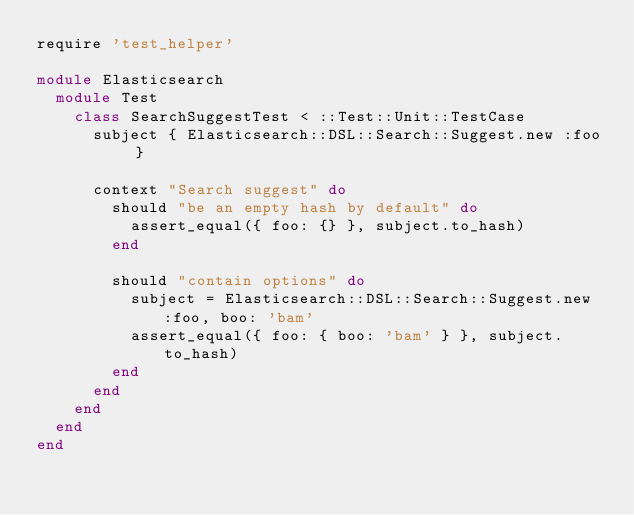<code> <loc_0><loc_0><loc_500><loc_500><_Ruby_>require 'test_helper'

module Elasticsearch
  module Test
    class SearchSuggestTest < ::Test::Unit::TestCase
      subject { Elasticsearch::DSL::Search::Suggest.new :foo }

      context "Search suggest" do
        should "be an empty hash by default" do
          assert_equal({ foo: {} }, subject.to_hash)
        end

        should "contain options" do
          subject = Elasticsearch::DSL::Search::Suggest.new :foo, boo: 'bam'
          assert_equal({ foo: { boo: 'bam' } }, subject.to_hash)
        end
      end
    end
  end
end
</code> 